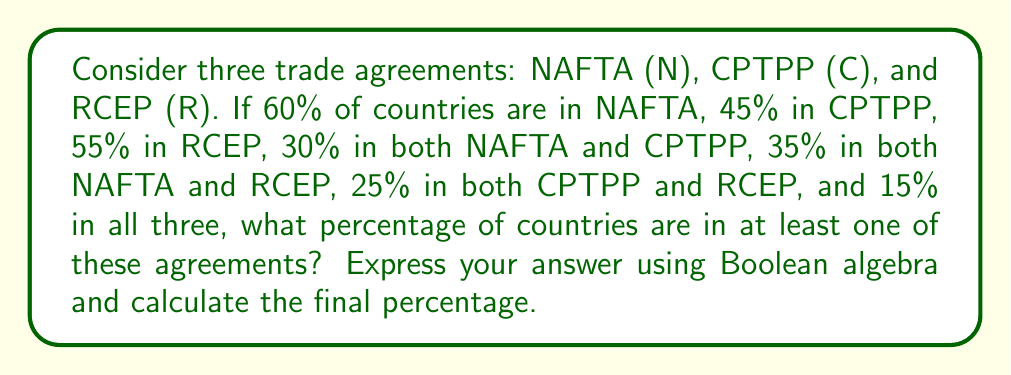What is the answer to this math problem? Let's approach this step-by-step using Boolean algebra:

1) First, we need to express the union of all three agreements:
   $N \cup C \cup R$

2) Using the Inclusion-Exclusion Principle, we can expand this:
   $|N \cup C \cup R| = |N| + |C| + |R| - |N \cap C| - |N \cap R| - |C \cap R| + |N \cap C \cap R|$

3) Now, let's substitute the given percentages:
   $|N \cup C \cup R| = 60\% + 45\% + 55\% - 30\% - 35\% - 25\% + 15\%$

4) Calculate:
   $|N \cup C \cup R| = 160\% - 90\% + 15\% = 85\%$

5) Therefore, 85% of countries are in at least one of these agreements.

This Boolean algebra approach allows us to account for overlaps between agreements without double-counting countries that are members of multiple agreements.
Answer: 85% 